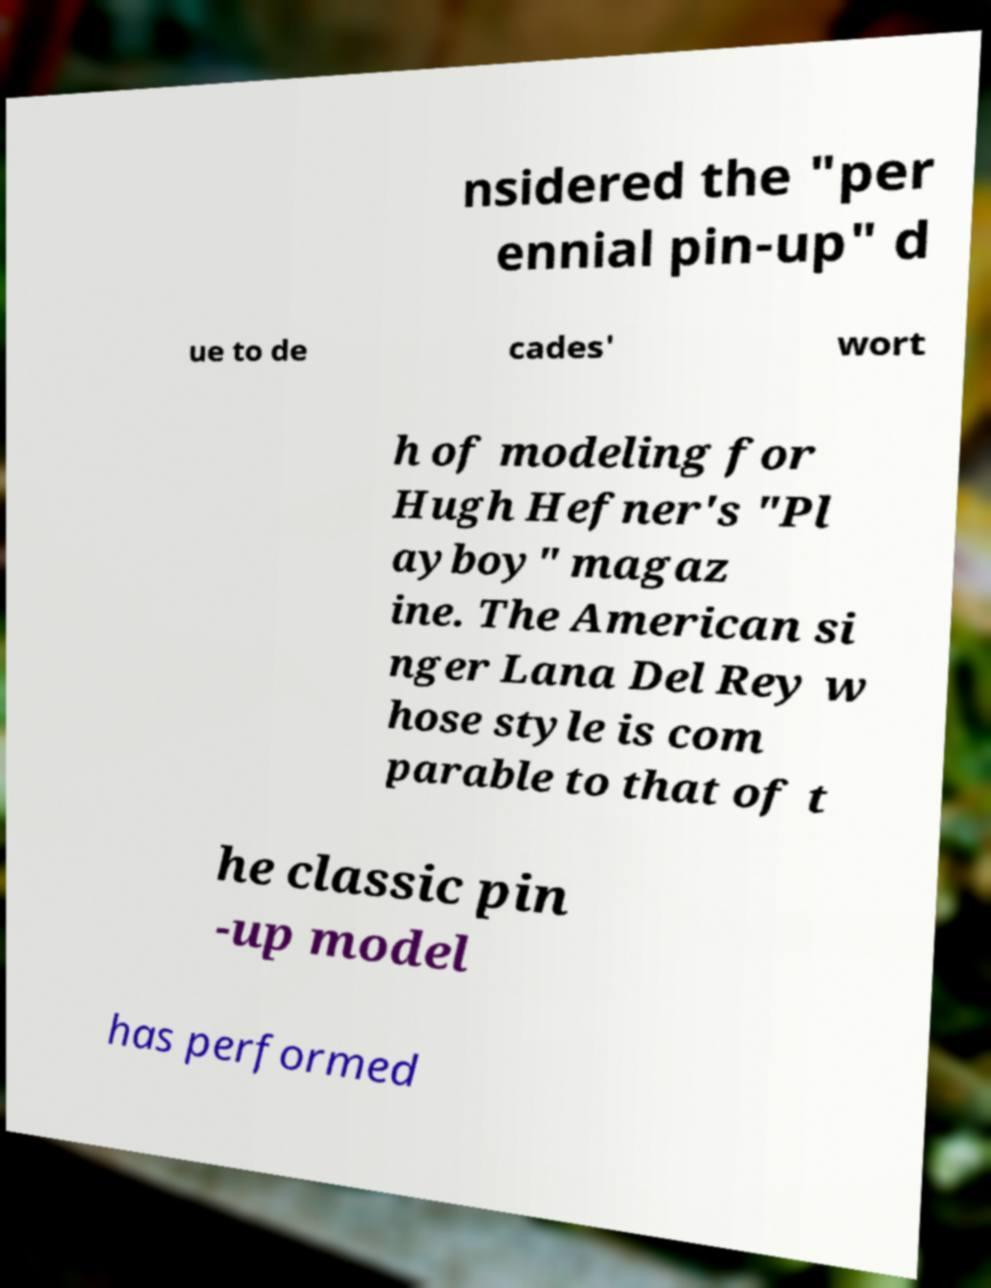Can you accurately transcribe the text from the provided image for me? nsidered the "per ennial pin-up" d ue to de cades' wort h of modeling for Hugh Hefner's "Pl ayboy" magaz ine. The American si nger Lana Del Rey w hose style is com parable to that of t he classic pin -up model has performed 